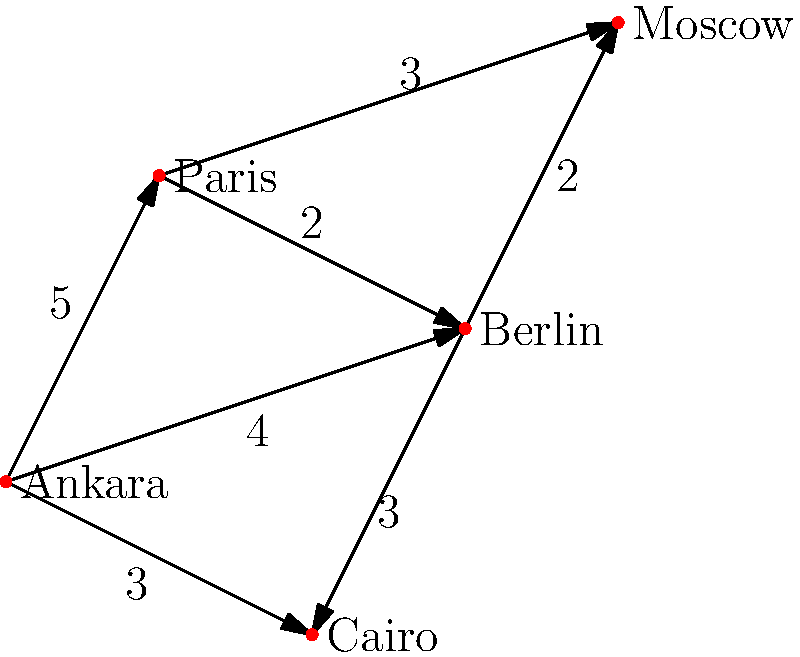As a Turkish diplomat, you need to efficiently plan a route from the embassy in Ankara to Moscow. Given the graph representing Turkish embassies in different countries and the travel times (in hours) between them, what is the shortest path from Ankara to Moscow, and how long does it take? To find the shortest path from Ankara to Moscow, we can use Dijkstra's algorithm or simply examine all possible paths:

1. Ankara → Paris → Moscow: 5 + 3 = 8 hours
2. Ankara → Berlin → Moscow: 4 + 2 = 6 hours
3. Ankara → Paris → Berlin → Moscow: 5 + 2 + 2 = 9 hours
4. Ankara → Cairo → Berlin → Moscow: 3 + 3 + 2 = 8 hours

The shortest path is Ankara → Berlin → Moscow, which takes 6 hours.

This route showcases Turkey's strategic location and its ability to efficiently connect with major European capitals, highlighting the importance of our diplomatic network in facilitating international relations.
Answer: Ankara → Berlin → Moscow, 6 hours 